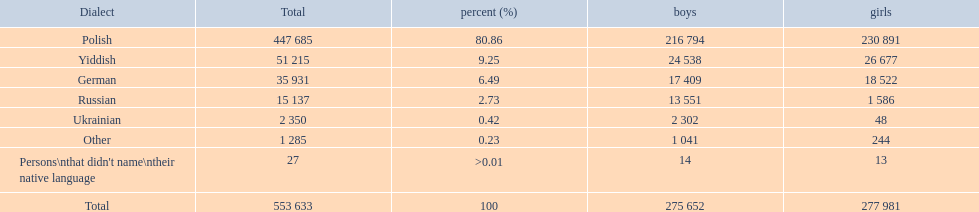What are the percentages of people? 80.86, 9.25, 6.49, 2.73, 0.42, 0.23, >0.01. Which language is .42%? Ukrainian. 